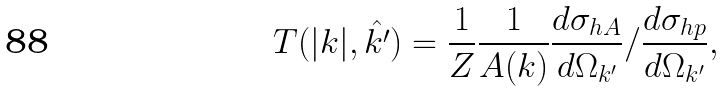Convert formula to latex. <formula><loc_0><loc_0><loc_500><loc_500>T ( | { k } | , \hat { k ^ { \prime } } ) = \frac { 1 } { Z } \frac { 1 } { A ( { k } ) } \frac { d \sigma _ { h A } } { d \Omega _ { k ^ { \prime } } } / \frac { d \sigma _ { h p } } { d \Omega _ { k ^ { \prime } } } ,</formula> 